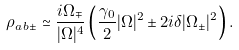<formula> <loc_0><loc_0><loc_500><loc_500>\rho _ { a \, b \pm } \simeq \frac { i \Omega _ { \mp } } { | \Omega | ^ { 4 } } \left ( \frac { \gamma _ { 0 } } { 2 } | \Omega | ^ { 2 } \pm 2 i \delta | \Omega _ { \pm } | ^ { 2 } \right ) .</formula> 